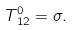<formula> <loc_0><loc_0><loc_500><loc_500>T ^ { 0 } _ { \, 1 2 } = \sigma .</formula> 